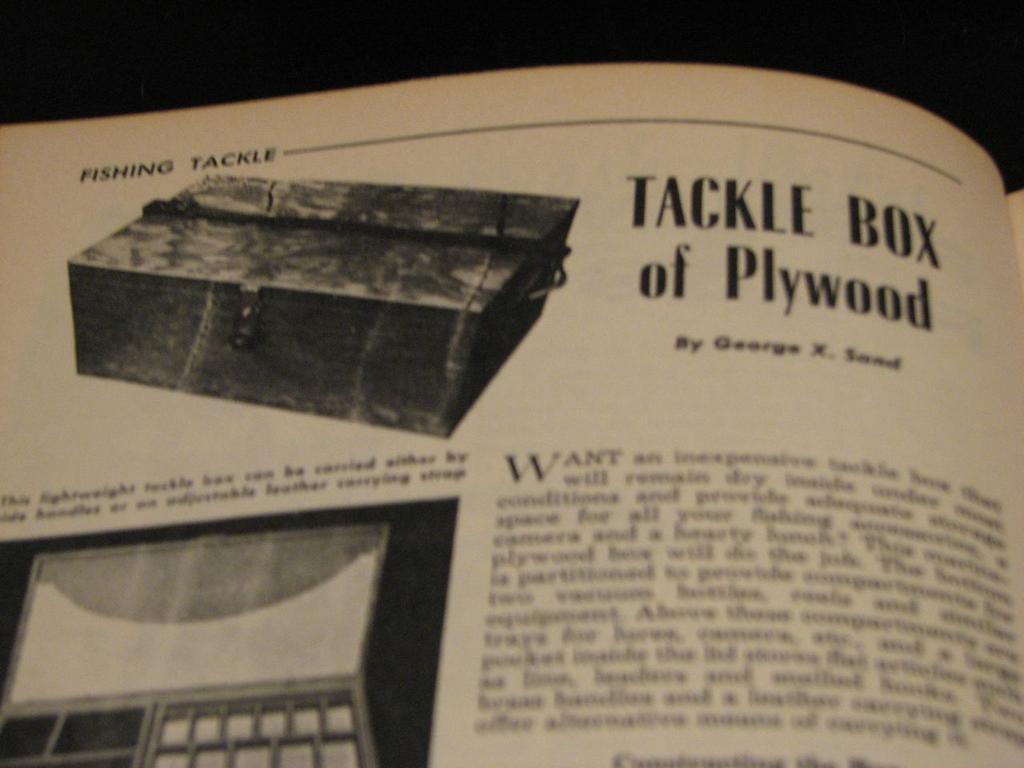What is the tackle box made out of?
Provide a short and direct response. Plywood. What type of box is this?
Make the answer very short. Tackle box. 